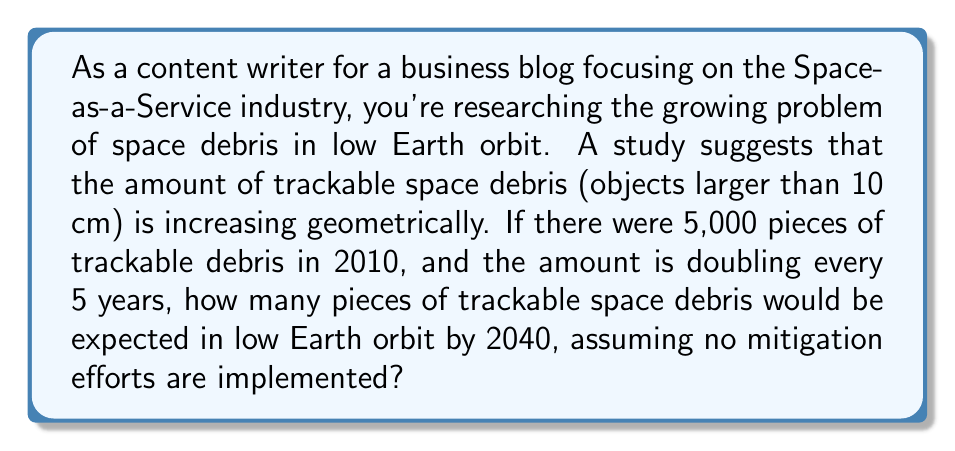Could you help me with this problem? To solve this problem, we need to use the concept of geometric series. Let's break it down step-by-step:

1) First, let's identify the important information:
   - Initial amount of debris in 2010: 5,000 pieces
   - The amount doubles every 5 years
   - We need to calculate the amount in 2040 (30 years from 2010)

2) This forms a geometric sequence with:
   - Initial term, $a = 5,000$
   - Common ratio, $r = 2$ (doubles every 5 years)
   - Number of 5-year periods from 2010 to 2040: $n = 6$ (30 years ÷ 5 years)

3) The formula for the nth term of a geometric sequence is:

   $$ a_n = a \cdot r^{n-1} $$

   Where $a_n$ is the nth term, $a$ is the first term, $r$ is the common ratio, and $n$ is the term number.

4) Plugging in our values:

   $$ a_6 = 5,000 \cdot 2^{6-1} = 5,000 \cdot 2^5 $$

5) Calculate:
   $$ a_6 = 5,000 \cdot 32 = 160,000 $$

Therefore, by 2040, there would be an expected 160,000 pieces of trackable space debris in low Earth orbit.
Answer: 160,000 pieces of trackable space debris 